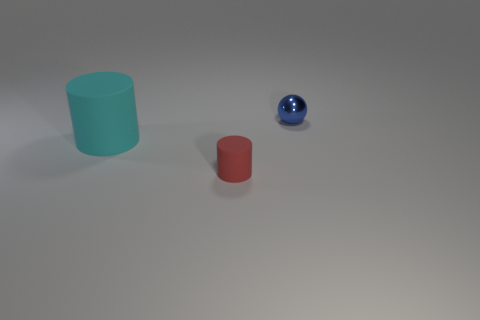What number of other objects are the same shape as the tiny red matte thing? There is one object that shares the same cylindrical shape as the small red matte one, which is the larger turquoise cylinder. 